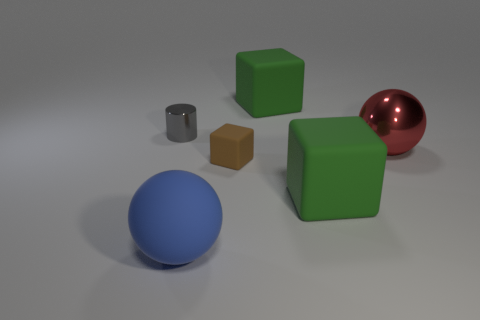Add 4 small yellow cylinders. How many objects exist? 10 Subtract all spheres. How many objects are left? 4 Add 3 small matte things. How many small matte things are left? 4 Add 4 small cylinders. How many small cylinders exist? 5 Subtract 0 purple spheres. How many objects are left? 6 Subtract all tiny red rubber spheres. Subtract all blue rubber spheres. How many objects are left? 5 